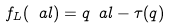<formula> <loc_0><loc_0><loc_500><loc_500>f _ { L } ( \ a l ) = q \ a l - \tau ( q )</formula> 